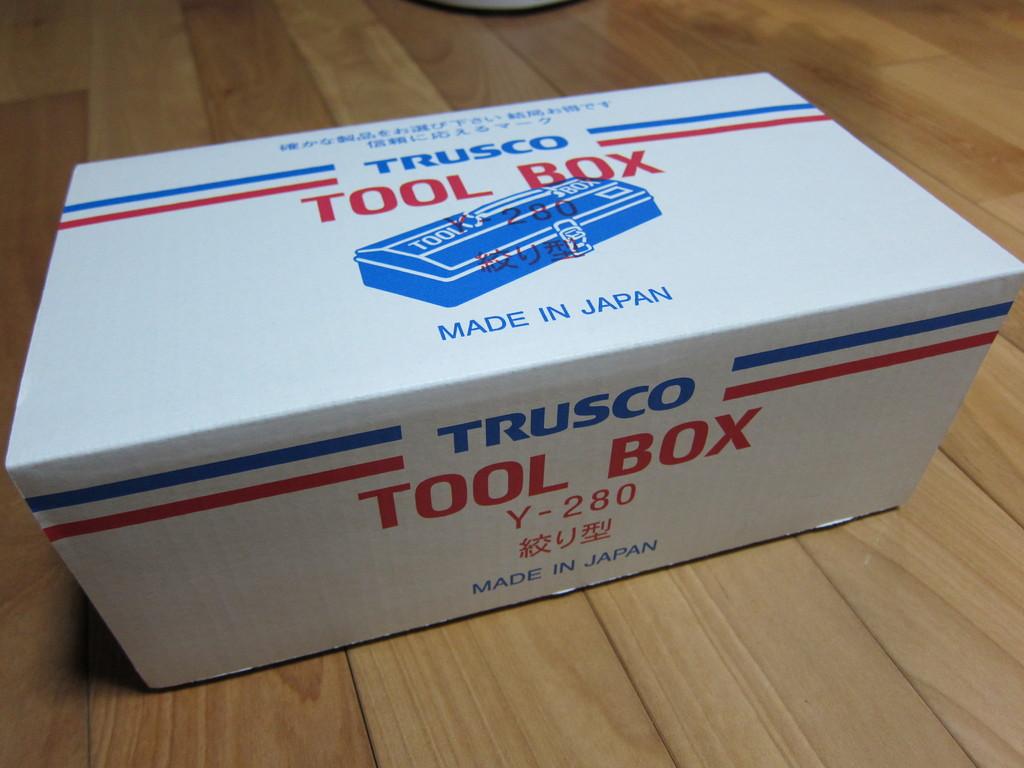What is inside the box?
Provide a succinct answer. Tools. This is made where?
Keep it short and to the point. Japan. 